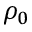<formula> <loc_0><loc_0><loc_500><loc_500>\rho _ { 0 }</formula> 